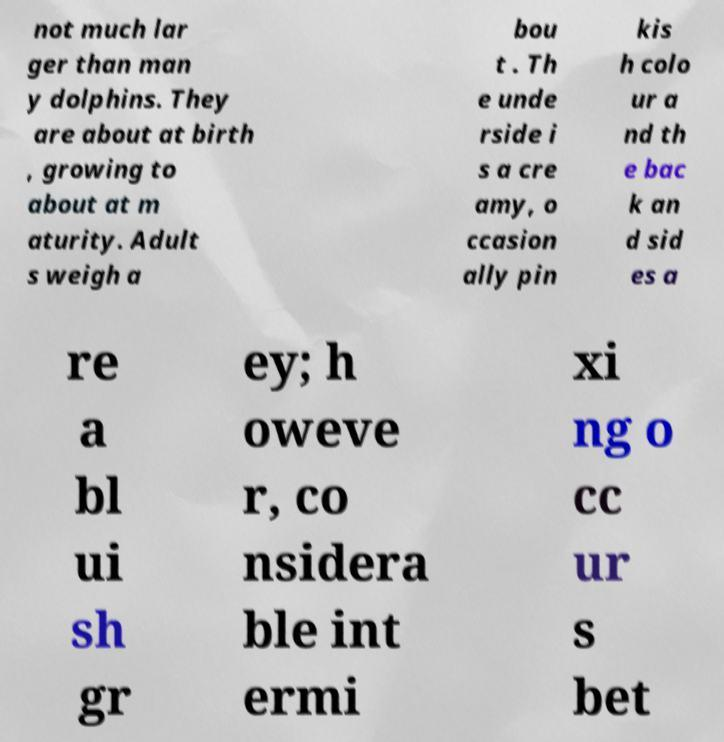Could you assist in decoding the text presented in this image and type it out clearly? not much lar ger than man y dolphins. They are about at birth , growing to about at m aturity. Adult s weigh a bou t . Th e unde rside i s a cre amy, o ccasion ally pin kis h colo ur a nd th e bac k an d sid es a re a bl ui sh gr ey; h oweve r, co nsidera ble int ermi xi ng o cc ur s bet 